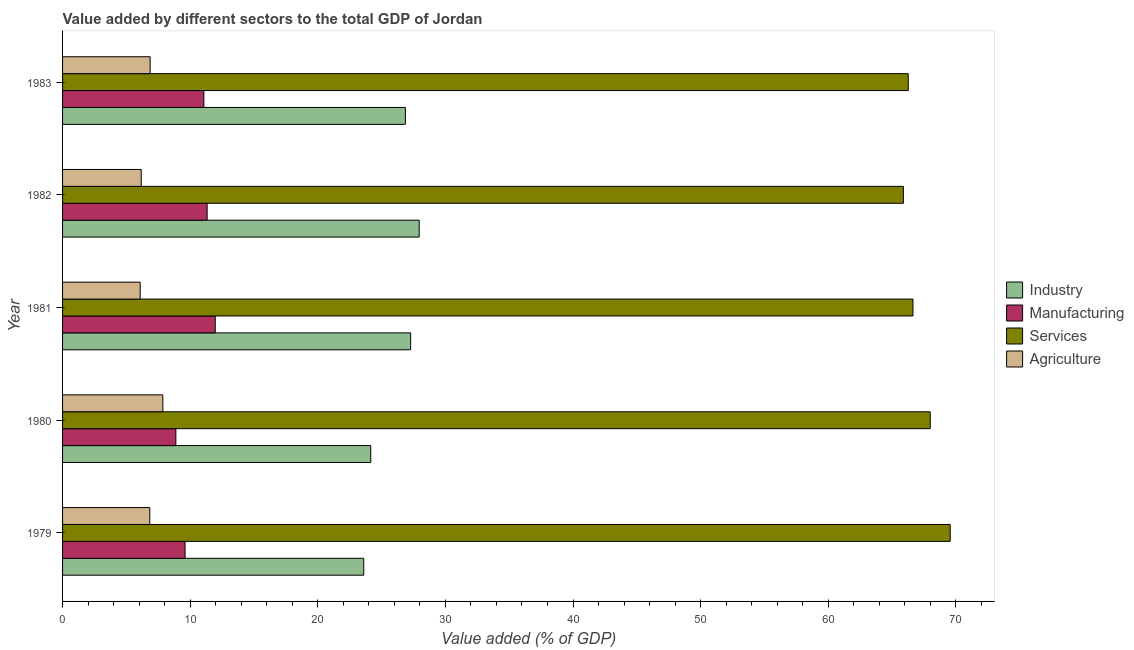How many groups of bars are there?
Provide a short and direct response. 5. Are the number of bars per tick equal to the number of legend labels?
Provide a short and direct response. Yes. Are the number of bars on each tick of the Y-axis equal?
Make the answer very short. Yes. How many bars are there on the 1st tick from the top?
Make the answer very short. 4. What is the value added by manufacturing sector in 1980?
Offer a terse response. 8.88. Across all years, what is the maximum value added by services sector?
Provide a succinct answer. 69.56. Across all years, what is the minimum value added by agricultural sector?
Keep it short and to the point. 6.08. In which year was the value added by industrial sector maximum?
Ensure brevity in your answer.  1982. In which year was the value added by manufacturing sector minimum?
Ensure brevity in your answer.  1980. What is the total value added by services sector in the graph?
Your answer should be compact. 336.35. What is the difference between the value added by services sector in 1979 and that in 1982?
Offer a very short reply. 3.67. What is the difference between the value added by industrial sector in 1982 and the value added by manufacturing sector in 1983?
Provide a succinct answer. 16.87. What is the average value added by agricultural sector per year?
Your answer should be very brief. 6.76. In the year 1980, what is the difference between the value added by services sector and value added by agricultural sector?
Offer a terse response. 60.13. What is the ratio of the value added by services sector in 1980 to that in 1982?
Your answer should be compact. 1.03. Is the difference between the value added by industrial sector in 1979 and 1980 greater than the difference between the value added by manufacturing sector in 1979 and 1980?
Provide a short and direct response. No. What is the difference between the highest and the second highest value added by industrial sector?
Your answer should be compact. 0.67. What is the difference between the highest and the lowest value added by manufacturing sector?
Ensure brevity in your answer.  3.09. In how many years, is the value added by services sector greater than the average value added by services sector taken over all years?
Provide a short and direct response. 2. Is the sum of the value added by manufacturing sector in 1980 and 1981 greater than the maximum value added by industrial sector across all years?
Make the answer very short. No. Is it the case that in every year, the sum of the value added by industrial sector and value added by manufacturing sector is greater than the sum of value added by agricultural sector and value added by services sector?
Provide a short and direct response. Yes. What does the 2nd bar from the top in 1982 represents?
Your response must be concise. Services. What does the 3rd bar from the bottom in 1979 represents?
Your answer should be very brief. Services. Is it the case that in every year, the sum of the value added by industrial sector and value added by manufacturing sector is greater than the value added by services sector?
Give a very brief answer. No. How many bars are there?
Your answer should be very brief. 20. Does the graph contain any zero values?
Make the answer very short. No. How many legend labels are there?
Make the answer very short. 4. What is the title of the graph?
Offer a very short reply. Value added by different sectors to the total GDP of Jordan. Does "Social Insurance" appear as one of the legend labels in the graph?
Provide a short and direct response. No. What is the label or title of the X-axis?
Provide a succinct answer. Value added (% of GDP). What is the label or title of the Y-axis?
Provide a short and direct response. Year. What is the Value added (% of GDP) in Industry in 1979?
Make the answer very short. 23.6. What is the Value added (% of GDP) in Manufacturing in 1979?
Offer a very short reply. 9.6. What is the Value added (% of GDP) of Services in 1979?
Your response must be concise. 69.56. What is the Value added (% of GDP) of Agriculture in 1979?
Provide a short and direct response. 6.84. What is the Value added (% of GDP) in Industry in 1980?
Your answer should be very brief. 24.15. What is the Value added (% of GDP) in Manufacturing in 1980?
Give a very brief answer. 8.88. What is the Value added (% of GDP) of Services in 1980?
Offer a very short reply. 67.99. What is the Value added (% of GDP) in Agriculture in 1980?
Provide a succinct answer. 7.86. What is the Value added (% of GDP) of Industry in 1981?
Make the answer very short. 27.28. What is the Value added (% of GDP) in Manufacturing in 1981?
Ensure brevity in your answer.  11.97. What is the Value added (% of GDP) of Services in 1981?
Your response must be concise. 66.64. What is the Value added (% of GDP) of Agriculture in 1981?
Keep it short and to the point. 6.08. What is the Value added (% of GDP) of Industry in 1982?
Your answer should be compact. 27.94. What is the Value added (% of GDP) in Manufacturing in 1982?
Keep it short and to the point. 11.33. What is the Value added (% of GDP) of Services in 1982?
Your answer should be compact. 65.89. What is the Value added (% of GDP) of Agriculture in 1982?
Your answer should be very brief. 6.16. What is the Value added (% of GDP) in Industry in 1983?
Your answer should be very brief. 26.87. What is the Value added (% of GDP) in Manufacturing in 1983?
Keep it short and to the point. 11.07. What is the Value added (% of GDP) of Services in 1983?
Provide a succinct answer. 66.27. What is the Value added (% of GDP) in Agriculture in 1983?
Offer a terse response. 6.86. Across all years, what is the maximum Value added (% of GDP) in Industry?
Offer a terse response. 27.94. Across all years, what is the maximum Value added (% of GDP) in Manufacturing?
Your response must be concise. 11.97. Across all years, what is the maximum Value added (% of GDP) in Services?
Your answer should be compact. 69.56. Across all years, what is the maximum Value added (% of GDP) of Agriculture?
Provide a succinct answer. 7.86. Across all years, what is the minimum Value added (% of GDP) in Industry?
Your response must be concise. 23.6. Across all years, what is the minimum Value added (% of GDP) in Manufacturing?
Provide a succinct answer. 8.88. Across all years, what is the minimum Value added (% of GDP) of Services?
Your answer should be very brief. 65.89. Across all years, what is the minimum Value added (% of GDP) of Agriculture?
Your answer should be compact. 6.08. What is the total Value added (% of GDP) of Industry in the graph?
Provide a short and direct response. 129.84. What is the total Value added (% of GDP) of Manufacturing in the graph?
Your response must be concise. 52.84. What is the total Value added (% of GDP) in Services in the graph?
Your answer should be very brief. 336.35. What is the total Value added (% of GDP) in Agriculture in the graph?
Make the answer very short. 33.8. What is the difference between the Value added (% of GDP) of Industry in 1979 and that in 1980?
Provide a succinct answer. -0.55. What is the difference between the Value added (% of GDP) in Manufacturing in 1979 and that in 1980?
Provide a short and direct response. 0.72. What is the difference between the Value added (% of GDP) of Services in 1979 and that in 1980?
Your answer should be compact. 1.57. What is the difference between the Value added (% of GDP) in Agriculture in 1979 and that in 1980?
Keep it short and to the point. -1.02. What is the difference between the Value added (% of GDP) of Industry in 1979 and that in 1981?
Offer a very short reply. -3.67. What is the difference between the Value added (% of GDP) of Manufacturing in 1979 and that in 1981?
Offer a terse response. -2.37. What is the difference between the Value added (% of GDP) of Services in 1979 and that in 1981?
Your answer should be very brief. 2.92. What is the difference between the Value added (% of GDP) in Agriculture in 1979 and that in 1981?
Give a very brief answer. 0.75. What is the difference between the Value added (% of GDP) of Industry in 1979 and that in 1982?
Give a very brief answer. -4.34. What is the difference between the Value added (% of GDP) of Manufacturing in 1979 and that in 1982?
Your answer should be compact. -1.73. What is the difference between the Value added (% of GDP) in Services in 1979 and that in 1982?
Provide a succinct answer. 3.67. What is the difference between the Value added (% of GDP) of Agriculture in 1979 and that in 1982?
Your answer should be compact. 0.67. What is the difference between the Value added (% of GDP) of Industry in 1979 and that in 1983?
Make the answer very short. -3.26. What is the difference between the Value added (% of GDP) in Manufacturing in 1979 and that in 1983?
Your answer should be very brief. -1.47. What is the difference between the Value added (% of GDP) in Services in 1979 and that in 1983?
Give a very brief answer. 3.29. What is the difference between the Value added (% of GDP) of Agriculture in 1979 and that in 1983?
Give a very brief answer. -0.03. What is the difference between the Value added (% of GDP) of Industry in 1980 and that in 1981?
Ensure brevity in your answer.  -3.13. What is the difference between the Value added (% of GDP) of Manufacturing in 1980 and that in 1981?
Your answer should be very brief. -3.09. What is the difference between the Value added (% of GDP) in Services in 1980 and that in 1981?
Offer a terse response. 1.35. What is the difference between the Value added (% of GDP) of Agriculture in 1980 and that in 1981?
Your answer should be compact. 1.78. What is the difference between the Value added (% of GDP) in Industry in 1980 and that in 1982?
Make the answer very short. -3.79. What is the difference between the Value added (% of GDP) in Manufacturing in 1980 and that in 1982?
Provide a succinct answer. -2.45. What is the difference between the Value added (% of GDP) of Services in 1980 and that in 1982?
Your answer should be very brief. 2.1. What is the difference between the Value added (% of GDP) of Agriculture in 1980 and that in 1982?
Offer a terse response. 1.69. What is the difference between the Value added (% of GDP) of Industry in 1980 and that in 1983?
Your response must be concise. -2.72. What is the difference between the Value added (% of GDP) of Manufacturing in 1980 and that in 1983?
Provide a short and direct response. -2.19. What is the difference between the Value added (% of GDP) in Services in 1980 and that in 1983?
Your answer should be very brief. 1.72. What is the difference between the Value added (% of GDP) of Industry in 1981 and that in 1982?
Keep it short and to the point. -0.67. What is the difference between the Value added (% of GDP) in Manufacturing in 1981 and that in 1982?
Your answer should be very brief. 0.64. What is the difference between the Value added (% of GDP) in Services in 1981 and that in 1982?
Keep it short and to the point. 0.75. What is the difference between the Value added (% of GDP) of Agriculture in 1981 and that in 1982?
Offer a very short reply. -0.08. What is the difference between the Value added (% of GDP) in Industry in 1981 and that in 1983?
Give a very brief answer. 0.41. What is the difference between the Value added (% of GDP) of Manufacturing in 1981 and that in 1983?
Keep it short and to the point. 0.89. What is the difference between the Value added (% of GDP) in Services in 1981 and that in 1983?
Your answer should be very brief. 0.37. What is the difference between the Value added (% of GDP) of Agriculture in 1981 and that in 1983?
Your response must be concise. -0.78. What is the difference between the Value added (% of GDP) of Industry in 1982 and that in 1983?
Offer a very short reply. 1.08. What is the difference between the Value added (% of GDP) of Manufacturing in 1982 and that in 1983?
Provide a short and direct response. 0.26. What is the difference between the Value added (% of GDP) in Services in 1982 and that in 1983?
Provide a short and direct response. -0.38. What is the difference between the Value added (% of GDP) in Agriculture in 1982 and that in 1983?
Provide a short and direct response. -0.7. What is the difference between the Value added (% of GDP) of Industry in 1979 and the Value added (% of GDP) of Manufacturing in 1980?
Ensure brevity in your answer.  14.73. What is the difference between the Value added (% of GDP) in Industry in 1979 and the Value added (% of GDP) in Services in 1980?
Ensure brevity in your answer.  -44.39. What is the difference between the Value added (% of GDP) in Industry in 1979 and the Value added (% of GDP) in Agriculture in 1980?
Provide a short and direct response. 15.75. What is the difference between the Value added (% of GDP) of Manufacturing in 1979 and the Value added (% of GDP) of Services in 1980?
Offer a terse response. -58.39. What is the difference between the Value added (% of GDP) in Manufacturing in 1979 and the Value added (% of GDP) in Agriculture in 1980?
Offer a very short reply. 1.74. What is the difference between the Value added (% of GDP) in Services in 1979 and the Value added (% of GDP) in Agriculture in 1980?
Give a very brief answer. 61.7. What is the difference between the Value added (% of GDP) in Industry in 1979 and the Value added (% of GDP) in Manufacturing in 1981?
Your response must be concise. 11.64. What is the difference between the Value added (% of GDP) in Industry in 1979 and the Value added (% of GDP) in Services in 1981?
Provide a short and direct response. -43.04. What is the difference between the Value added (% of GDP) of Industry in 1979 and the Value added (% of GDP) of Agriculture in 1981?
Keep it short and to the point. 17.52. What is the difference between the Value added (% of GDP) in Manufacturing in 1979 and the Value added (% of GDP) in Services in 1981?
Offer a terse response. -57.04. What is the difference between the Value added (% of GDP) in Manufacturing in 1979 and the Value added (% of GDP) in Agriculture in 1981?
Keep it short and to the point. 3.52. What is the difference between the Value added (% of GDP) in Services in 1979 and the Value added (% of GDP) in Agriculture in 1981?
Make the answer very short. 63.48. What is the difference between the Value added (% of GDP) of Industry in 1979 and the Value added (% of GDP) of Manufacturing in 1982?
Offer a terse response. 12.28. What is the difference between the Value added (% of GDP) of Industry in 1979 and the Value added (% of GDP) of Services in 1982?
Your answer should be compact. -42.29. What is the difference between the Value added (% of GDP) in Industry in 1979 and the Value added (% of GDP) in Agriculture in 1982?
Keep it short and to the point. 17.44. What is the difference between the Value added (% of GDP) in Manufacturing in 1979 and the Value added (% of GDP) in Services in 1982?
Keep it short and to the point. -56.29. What is the difference between the Value added (% of GDP) of Manufacturing in 1979 and the Value added (% of GDP) of Agriculture in 1982?
Your answer should be compact. 3.43. What is the difference between the Value added (% of GDP) in Services in 1979 and the Value added (% of GDP) in Agriculture in 1982?
Offer a very short reply. 63.39. What is the difference between the Value added (% of GDP) in Industry in 1979 and the Value added (% of GDP) in Manufacturing in 1983?
Offer a terse response. 12.53. What is the difference between the Value added (% of GDP) in Industry in 1979 and the Value added (% of GDP) in Services in 1983?
Your response must be concise. -42.67. What is the difference between the Value added (% of GDP) of Industry in 1979 and the Value added (% of GDP) of Agriculture in 1983?
Give a very brief answer. 16.74. What is the difference between the Value added (% of GDP) in Manufacturing in 1979 and the Value added (% of GDP) in Services in 1983?
Provide a succinct answer. -56.67. What is the difference between the Value added (% of GDP) in Manufacturing in 1979 and the Value added (% of GDP) in Agriculture in 1983?
Give a very brief answer. 2.74. What is the difference between the Value added (% of GDP) of Services in 1979 and the Value added (% of GDP) of Agriculture in 1983?
Make the answer very short. 62.7. What is the difference between the Value added (% of GDP) of Industry in 1980 and the Value added (% of GDP) of Manufacturing in 1981?
Your answer should be compact. 12.18. What is the difference between the Value added (% of GDP) of Industry in 1980 and the Value added (% of GDP) of Services in 1981?
Your answer should be compact. -42.49. What is the difference between the Value added (% of GDP) of Industry in 1980 and the Value added (% of GDP) of Agriculture in 1981?
Offer a terse response. 18.07. What is the difference between the Value added (% of GDP) of Manufacturing in 1980 and the Value added (% of GDP) of Services in 1981?
Offer a terse response. -57.76. What is the difference between the Value added (% of GDP) in Manufacturing in 1980 and the Value added (% of GDP) in Agriculture in 1981?
Offer a very short reply. 2.8. What is the difference between the Value added (% of GDP) of Services in 1980 and the Value added (% of GDP) of Agriculture in 1981?
Make the answer very short. 61.91. What is the difference between the Value added (% of GDP) in Industry in 1980 and the Value added (% of GDP) in Manufacturing in 1982?
Give a very brief answer. 12.82. What is the difference between the Value added (% of GDP) of Industry in 1980 and the Value added (% of GDP) of Services in 1982?
Your answer should be very brief. -41.74. What is the difference between the Value added (% of GDP) in Industry in 1980 and the Value added (% of GDP) in Agriculture in 1982?
Your answer should be very brief. 17.98. What is the difference between the Value added (% of GDP) of Manufacturing in 1980 and the Value added (% of GDP) of Services in 1982?
Offer a very short reply. -57.01. What is the difference between the Value added (% of GDP) of Manufacturing in 1980 and the Value added (% of GDP) of Agriculture in 1982?
Offer a terse response. 2.71. What is the difference between the Value added (% of GDP) of Services in 1980 and the Value added (% of GDP) of Agriculture in 1982?
Give a very brief answer. 61.83. What is the difference between the Value added (% of GDP) of Industry in 1980 and the Value added (% of GDP) of Manufacturing in 1983?
Your answer should be compact. 13.08. What is the difference between the Value added (% of GDP) in Industry in 1980 and the Value added (% of GDP) in Services in 1983?
Ensure brevity in your answer.  -42.12. What is the difference between the Value added (% of GDP) of Industry in 1980 and the Value added (% of GDP) of Agriculture in 1983?
Offer a terse response. 17.29. What is the difference between the Value added (% of GDP) of Manufacturing in 1980 and the Value added (% of GDP) of Services in 1983?
Give a very brief answer. -57.39. What is the difference between the Value added (% of GDP) in Manufacturing in 1980 and the Value added (% of GDP) in Agriculture in 1983?
Keep it short and to the point. 2.01. What is the difference between the Value added (% of GDP) in Services in 1980 and the Value added (% of GDP) in Agriculture in 1983?
Provide a short and direct response. 61.13. What is the difference between the Value added (% of GDP) in Industry in 1981 and the Value added (% of GDP) in Manufacturing in 1982?
Provide a succinct answer. 15.95. What is the difference between the Value added (% of GDP) in Industry in 1981 and the Value added (% of GDP) in Services in 1982?
Provide a short and direct response. -38.61. What is the difference between the Value added (% of GDP) in Industry in 1981 and the Value added (% of GDP) in Agriculture in 1982?
Your answer should be compact. 21.11. What is the difference between the Value added (% of GDP) in Manufacturing in 1981 and the Value added (% of GDP) in Services in 1982?
Provide a short and direct response. -53.92. What is the difference between the Value added (% of GDP) of Manufacturing in 1981 and the Value added (% of GDP) of Agriculture in 1982?
Your response must be concise. 5.8. What is the difference between the Value added (% of GDP) of Services in 1981 and the Value added (% of GDP) of Agriculture in 1982?
Provide a short and direct response. 60.48. What is the difference between the Value added (% of GDP) in Industry in 1981 and the Value added (% of GDP) in Manufacturing in 1983?
Offer a terse response. 16.2. What is the difference between the Value added (% of GDP) in Industry in 1981 and the Value added (% of GDP) in Services in 1983?
Your response must be concise. -38.99. What is the difference between the Value added (% of GDP) in Industry in 1981 and the Value added (% of GDP) in Agriculture in 1983?
Provide a succinct answer. 20.41. What is the difference between the Value added (% of GDP) in Manufacturing in 1981 and the Value added (% of GDP) in Services in 1983?
Your answer should be very brief. -54.31. What is the difference between the Value added (% of GDP) in Manufacturing in 1981 and the Value added (% of GDP) in Agriculture in 1983?
Give a very brief answer. 5.1. What is the difference between the Value added (% of GDP) in Services in 1981 and the Value added (% of GDP) in Agriculture in 1983?
Your answer should be very brief. 59.78. What is the difference between the Value added (% of GDP) in Industry in 1982 and the Value added (% of GDP) in Manufacturing in 1983?
Make the answer very short. 16.87. What is the difference between the Value added (% of GDP) of Industry in 1982 and the Value added (% of GDP) of Services in 1983?
Keep it short and to the point. -38.33. What is the difference between the Value added (% of GDP) of Industry in 1982 and the Value added (% of GDP) of Agriculture in 1983?
Offer a terse response. 21.08. What is the difference between the Value added (% of GDP) of Manufacturing in 1982 and the Value added (% of GDP) of Services in 1983?
Your response must be concise. -54.94. What is the difference between the Value added (% of GDP) of Manufacturing in 1982 and the Value added (% of GDP) of Agriculture in 1983?
Offer a very short reply. 4.46. What is the difference between the Value added (% of GDP) in Services in 1982 and the Value added (% of GDP) in Agriculture in 1983?
Provide a short and direct response. 59.03. What is the average Value added (% of GDP) in Industry per year?
Ensure brevity in your answer.  25.97. What is the average Value added (% of GDP) of Manufacturing per year?
Keep it short and to the point. 10.57. What is the average Value added (% of GDP) of Services per year?
Ensure brevity in your answer.  67.27. What is the average Value added (% of GDP) in Agriculture per year?
Keep it short and to the point. 6.76. In the year 1979, what is the difference between the Value added (% of GDP) in Industry and Value added (% of GDP) in Manufacturing?
Give a very brief answer. 14.01. In the year 1979, what is the difference between the Value added (% of GDP) in Industry and Value added (% of GDP) in Services?
Ensure brevity in your answer.  -45.95. In the year 1979, what is the difference between the Value added (% of GDP) in Industry and Value added (% of GDP) in Agriculture?
Provide a succinct answer. 16.77. In the year 1979, what is the difference between the Value added (% of GDP) in Manufacturing and Value added (% of GDP) in Services?
Provide a succinct answer. -59.96. In the year 1979, what is the difference between the Value added (% of GDP) of Manufacturing and Value added (% of GDP) of Agriculture?
Offer a terse response. 2.76. In the year 1979, what is the difference between the Value added (% of GDP) in Services and Value added (% of GDP) in Agriculture?
Ensure brevity in your answer.  62.72. In the year 1980, what is the difference between the Value added (% of GDP) in Industry and Value added (% of GDP) in Manufacturing?
Offer a very short reply. 15.27. In the year 1980, what is the difference between the Value added (% of GDP) in Industry and Value added (% of GDP) in Services?
Keep it short and to the point. -43.84. In the year 1980, what is the difference between the Value added (% of GDP) of Industry and Value added (% of GDP) of Agriculture?
Offer a very short reply. 16.29. In the year 1980, what is the difference between the Value added (% of GDP) in Manufacturing and Value added (% of GDP) in Services?
Offer a terse response. -59.11. In the year 1980, what is the difference between the Value added (% of GDP) of Services and Value added (% of GDP) of Agriculture?
Make the answer very short. 60.13. In the year 1981, what is the difference between the Value added (% of GDP) in Industry and Value added (% of GDP) in Manufacturing?
Your answer should be very brief. 15.31. In the year 1981, what is the difference between the Value added (% of GDP) in Industry and Value added (% of GDP) in Services?
Provide a succinct answer. -39.36. In the year 1981, what is the difference between the Value added (% of GDP) in Industry and Value added (% of GDP) in Agriculture?
Your response must be concise. 21.2. In the year 1981, what is the difference between the Value added (% of GDP) of Manufacturing and Value added (% of GDP) of Services?
Offer a very short reply. -54.68. In the year 1981, what is the difference between the Value added (% of GDP) in Manufacturing and Value added (% of GDP) in Agriculture?
Your answer should be compact. 5.88. In the year 1981, what is the difference between the Value added (% of GDP) of Services and Value added (% of GDP) of Agriculture?
Keep it short and to the point. 60.56. In the year 1982, what is the difference between the Value added (% of GDP) of Industry and Value added (% of GDP) of Manufacturing?
Provide a succinct answer. 16.62. In the year 1982, what is the difference between the Value added (% of GDP) of Industry and Value added (% of GDP) of Services?
Your response must be concise. -37.95. In the year 1982, what is the difference between the Value added (% of GDP) of Industry and Value added (% of GDP) of Agriculture?
Your answer should be compact. 21.78. In the year 1982, what is the difference between the Value added (% of GDP) of Manufacturing and Value added (% of GDP) of Services?
Offer a very short reply. -54.56. In the year 1982, what is the difference between the Value added (% of GDP) in Manufacturing and Value added (% of GDP) in Agriculture?
Provide a short and direct response. 5.16. In the year 1982, what is the difference between the Value added (% of GDP) of Services and Value added (% of GDP) of Agriculture?
Give a very brief answer. 59.73. In the year 1983, what is the difference between the Value added (% of GDP) in Industry and Value added (% of GDP) in Manufacturing?
Keep it short and to the point. 15.79. In the year 1983, what is the difference between the Value added (% of GDP) in Industry and Value added (% of GDP) in Services?
Give a very brief answer. -39.41. In the year 1983, what is the difference between the Value added (% of GDP) of Industry and Value added (% of GDP) of Agriculture?
Provide a short and direct response. 20. In the year 1983, what is the difference between the Value added (% of GDP) of Manufacturing and Value added (% of GDP) of Services?
Your answer should be compact. -55.2. In the year 1983, what is the difference between the Value added (% of GDP) in Manufacturing and Value added (% of GDP) in Agriculture?
Offer a terse response. 4.21. In the year 1983, what is the difference between the Value added (% of GDP) in Services and Value added (% of GDP) in Agriculture?
Make the answer very short. 59.41. What is the ratio of the Value added (% of GDP) in Industry in 1979 to that in 1980?
Provide a succinct answer. 0.98. What is the ratio of the Value added (% of GDP) in Manufacturing in 1979 to that in 1980?
Ensure brevity in your answer.  1.08. What is the ratio of the Value added (% of GDP) of Services in 1979 to that in 1980?
Provide a succinct answer. 1.02. What is the ratio of the Value added (% of GDP) in Agriculture in 1979 to that in 1980?
Provide a succinct answer. 0.87. What is the ratio of the Value added (% of GDP) in Industry in 1979 to that in 1981?
Ensure brevity in your answer.  0.87. What is the ratio of the Value added (% of GDP) of Manufacturing in 1979 to that in 1981?
Your response must be concise. 0.8. What is the ratio of the Value added (% of GDP) in Services in 1979 to that in 1981?
Your response must be concise. 1.04. What is the ratio of the Value added (% of GDP) in Agriculture in 1979 to that in 1981?
Your response must be concise. 1.12. What is the ratio of the Value added (% of GDP) in Industry in 1979 to that in 1982?
Your answer should be very brief. 0.84. What is the ratio of the Value added (% of GDP) of Manufacturing in 1979 to that in 1982?
Provide a short and direct response. 0.85. What is the ratio of the Value added (% of GDP) of Services in 1979 to that in 1982?
Keep it short and to the point. 1.06. What is the ratio of the Value added (% of GDP) in Agriculture in 1979 to that in 1982?
Your response must be concise. 1.11. What is the ratio of the Value added (% of GDP) in Industry in 1979 to that in 1983?
Give a very brief answer. 0.88. What is the ratio of the Value added (% of GDP) in Manufacturing in 1979 to that in 1983?
Your answer should be compact. 0.87. What is the ratio of the Value added (% of GDP) of Services in 1979 to that in 1983?
Give a very brief answer. 1.05. What is the ratio of the Value added (% of GDP) of Agriculture in 1979 to that in 1983?
Your response must be concise. 1. What is the ratio of the Value added (% of GDP) of Industry in 1980 to that in 1981?
Offer a very short reply. 0.89. What is the ratio of the Value added (% of GDP) of Manufacturing in 1980 to that in 1981?
Keep it short and to the point. 0.74. What is the ratio of the Value added (% of GDP) of Services in 1980 to that in 1981?
Ensure brevity in your answer.  1.02. What is the ratio of the Value added (% of GDP) in Agriculture in 1980 to that in 1981?
Provide a succinct answer. 1.29. What is the ratio of the Value added (% of GDP) in Industry in 1980 to that in 1982?
Provide a short and direct response. 0.86. What is the ratio of the Value added (% of GDP) in Manufacturing in 1980 to that in 1982?
Make the answer very short. 0.78. What is the ratio of the Value added (% of GDP) in Services in 1980 to that in 1982?
Your response must be concise. 1.03. What is the ratio of the Value added (% of GDP) of Agriculture in 1980 to that in 1982?
Your response must be concise. 1.27. What is the ratio of the Value added (% of GDP) of Industry in 1980 to that in 1983?
Your answer should be very brief. 0.9. What is the ratio of the Value added (% of GDP) in Manufacturing in 1980 to that in 1983?
Give a very brief answer. 0.8. What is the ratio of the Value added (% of GDP) in Services in 1980 to that in 1983?
Ensure brevity in your answer.  1.03. What is the ratio of the Value added (% of GDP) in Agriculture in 1980 to that in 1983?
Your response must be concise. 1.14. What is the ratio of the Value added (% of GDP) in Industry in 1981 to that in 1982?
Offer a very short reply. 0.98. What is the ratio of the Value added (% of GDP) in Manufacturing in 1981 to that in 1982?
Your answer should be compact. 1.06. What is the ratio of the Value added (% of GDP) of Services in 1981 to that in 1982?
Make the answer very short. 1.01. What is the ratio of the Value added (% of GDP) of Agriculture in 1981 to that in 1982?
Your answer should be compact. 0.99. What is the ratio of the Value added (% of GDP) in Industry in 1981 to that in 1983?
Ensure brevity in your answer.  1.02. What is the ratio of the Value added (% of GDP) in Manufacturing in 1981 to that in 1983?
Your response must be concise. 1.08. What is the ratio of the Value added (% of GDP) of Services in 1981 to that in 1983?
Your response must be concise. 1.01. What is the ratio of the Value added (% of GDP) in Agriculture in 1981 to that in 1983?
Offer a terse response. 0.89. What is the ratio of the Value added (% of GDP) in Industry in 1982 to that in 1983?
Offer a terse response. 1.04. What is the ratio of the Value added (% of GDP) in Manufacturing in 1982 to that in 1983?
Your answer should be very brief. 1.02. What is the ratio of the Value added (% of GDP) in Agriculture in 1982 to that in 1983?
Your answer should be very brief. 0.9. What is the difference between the highest and the second highest Value added (% of GDP) of Industry?
Offer a very short reply. 0.67. What is the difference between the highest and the second highest Value added (% of GDP) of Manufacturing?
Offer a terse response. 0.64. What is the difference between the highest and the second highest Value added (% of GDP) of Services?
Offer a very short reply. 1.57. What is the difference between the highest and the lowest Value added (% of GDP) in Industry?
Provide a succinct answer. 4.34. What is the difference between the highest and the lowest Value added (% of GDP) of Manufacturing?
Make the answer very short. 3.09. What is the difference between the highest and the lowest Value added (% of GDP) in Services?
Provide a short and direct response. 3.67. What is the difference between the highest and the lowest Value added (% of GDP) of Agriculture?
Your answer should be compact. 1.78. 